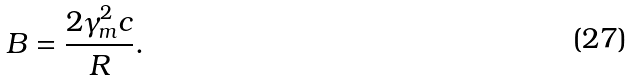Convert formula to latex. <formula><loc_0><loc_0><loc_500><loc_500>B = \frac { 2 \gamma _ { m } ^ { 2 } c } { R } .</formula> 